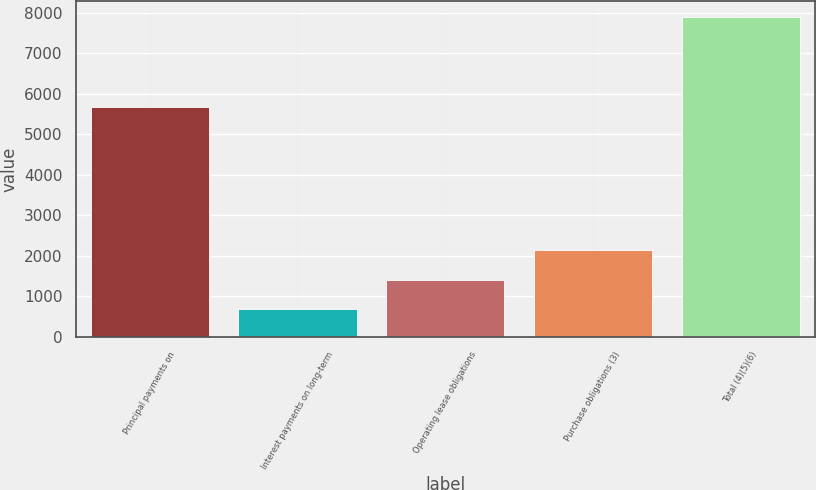Convert chart to OTSL. <chart><loc_0><loc_0><loc_500><loc_500><bar_chart><fcel>Principal payments on<fcel>Interest payments on long-term<fcel>Operating lease obligations<fcel>Purchase obligations (3)<fcel>Total (4)(5)(6)<nl><fcel>5671<fcel>694<fcel>1415.1<fcel>2136.2<fcel>7905<nl></chart> 